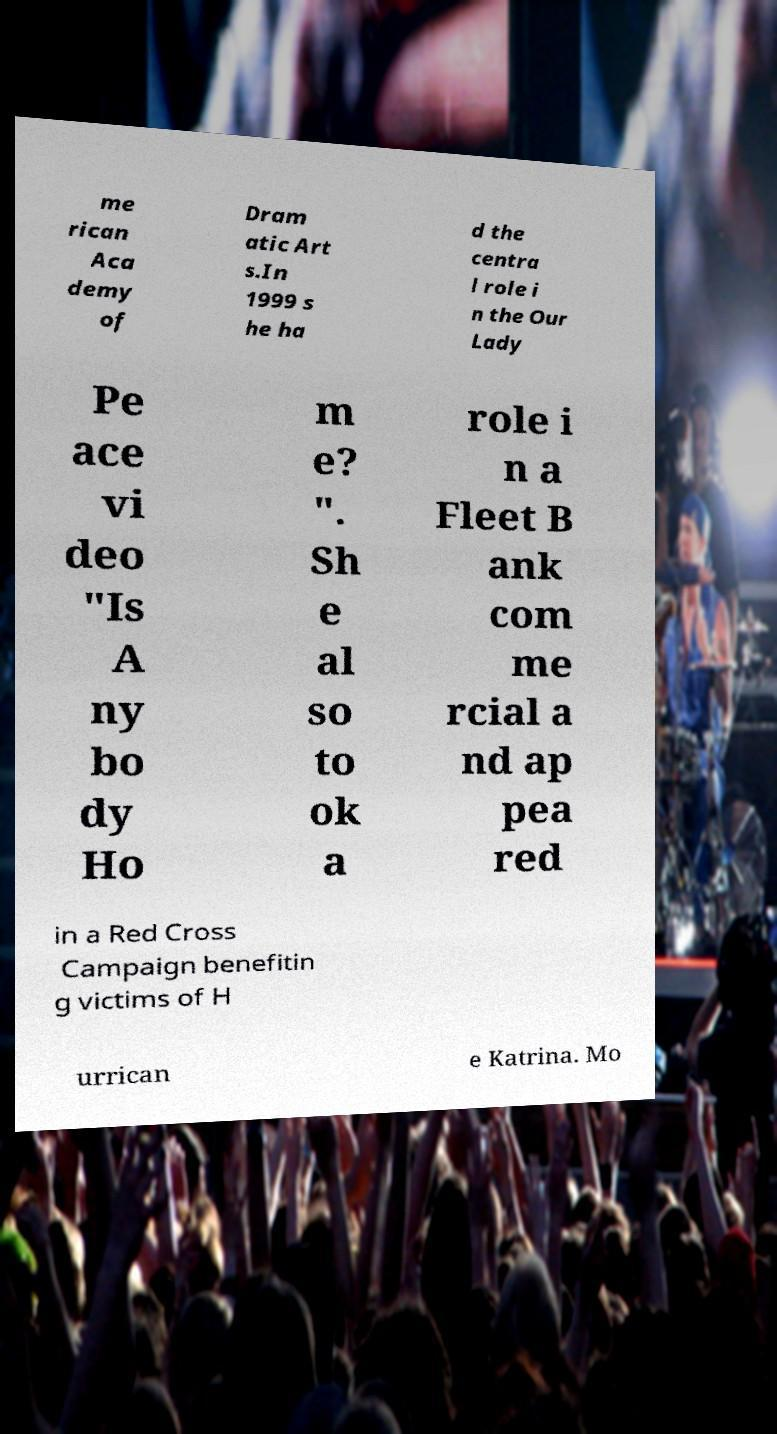Could you assist in decoding the text presented in this image and type it out clearly? me rican Aca demy of Dram atic Art s.In 1999 s he ha d the centra l role i n the Our Lady Pe ace vi deo "Is A ny bo dy Ho m e? ". Sh e al so to ok a role i n a Fleet B ank com me rcial a nd ap pea red in a Red Cross Campaign benefitin g victims of H urrican e Katrina. Mo 